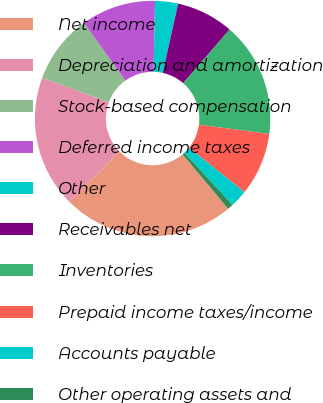Convert chart. <chart><loc_0><loc_0><loc_500><loc_500><pie_chart><fcel>Net income<fcel>Depreciation and amortization<fcel>Stock-based compensation<fcel>Deferred income taxes<fcel>Other<fcel>Receivables net<fcel>Inventories<fcel>Prepaid income taxes/income<fcel>Accounts payable<fcel>Other operating assets and<nl><fcel>23.62%<fcel>18.11%<fcel>9.45%<fcel>10.24%<fcel>3.15%<fcel>7.87%<fcel>15.75%<fcel>8.66%<fcel>2.36%<fcel>0.79%<nl></chart> 